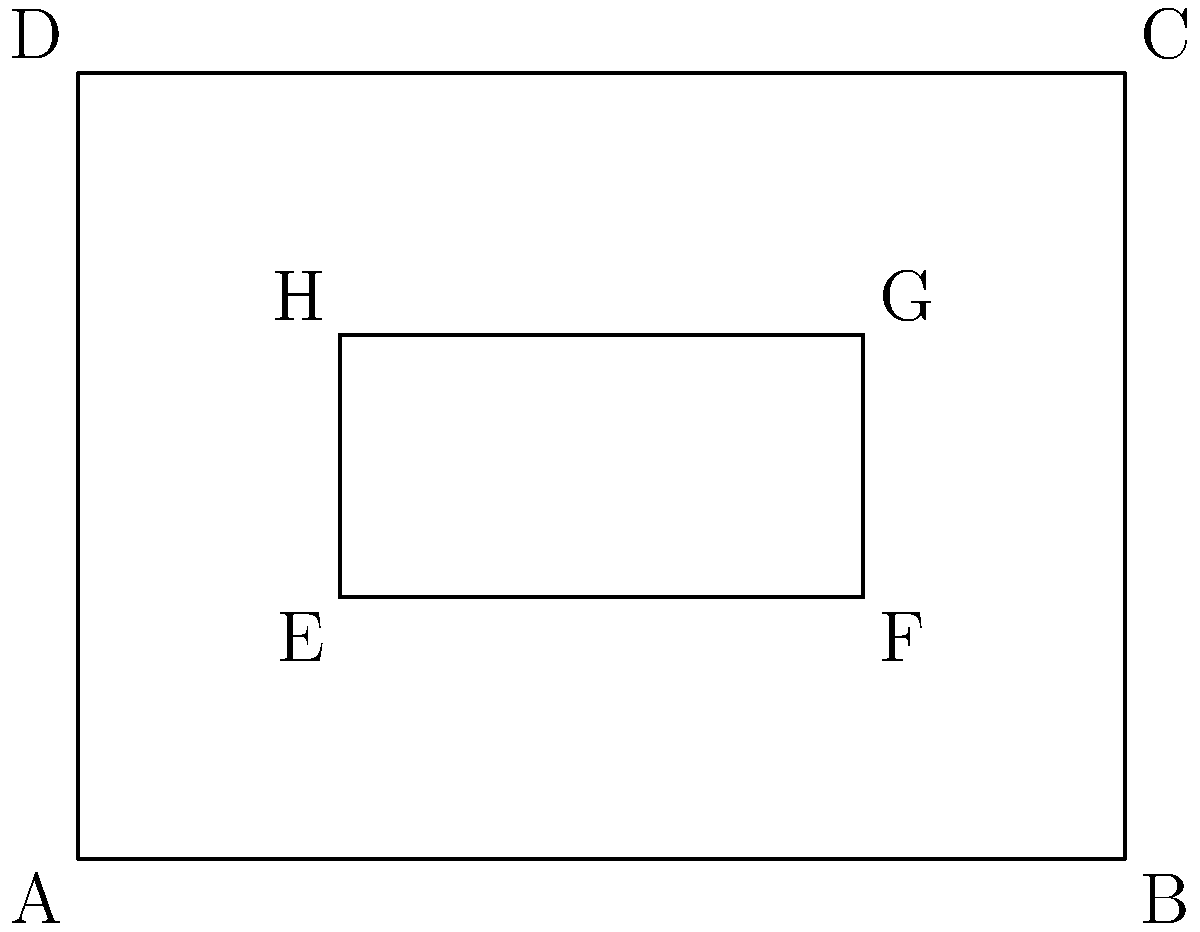In a simplified game map, you encounter two rectangular areas represented by ABCD and EFGH. If the scale of the map is consistent throughout, and you know that AB = 4 units and BC = 3 units, how can you prove that EFGH is congruent to a rectangle with dimensions 2 units by 1 unit? To prove that EFGH is congruent to a rectangle with dimensions 2 units by 1 unit, we can follow these steps:

1) First, let's analyze the given information:
   - ABCD is a rectangle with AB = 4 units and BC = 3 units
   - EFGH is also a rectangle inside ABCD

2) Observe the position of EFGH within ABCD:
   - E is 1 unit away from A in both x and y directions
   - H is 1 unit away from D in both x and y directions

3) Calculate the dimensions of EFGH:
   - EF = AB - (AE + BF) = 4 - (1 + 1) = 2 units
   - EH = BC - (BE + CH) = 3 - (1 + 1) = 1 unit

4) Congruence criteria:
   - For rectangles to be congruent, they must have the same dimensions
   - EFGH has dimensions 2 units by 1 unit

5) Therefore, EFGH is congruent to a rectangle with dimensions 2 units by 1 unit, as it has exactly these dimensions.

The scale consistency in the map ensures that the proportions and measurements are maintained throughout, allowing us to make these calculations and comparisons accurately.
Answer: EFGH has dimensions 2x1 units 